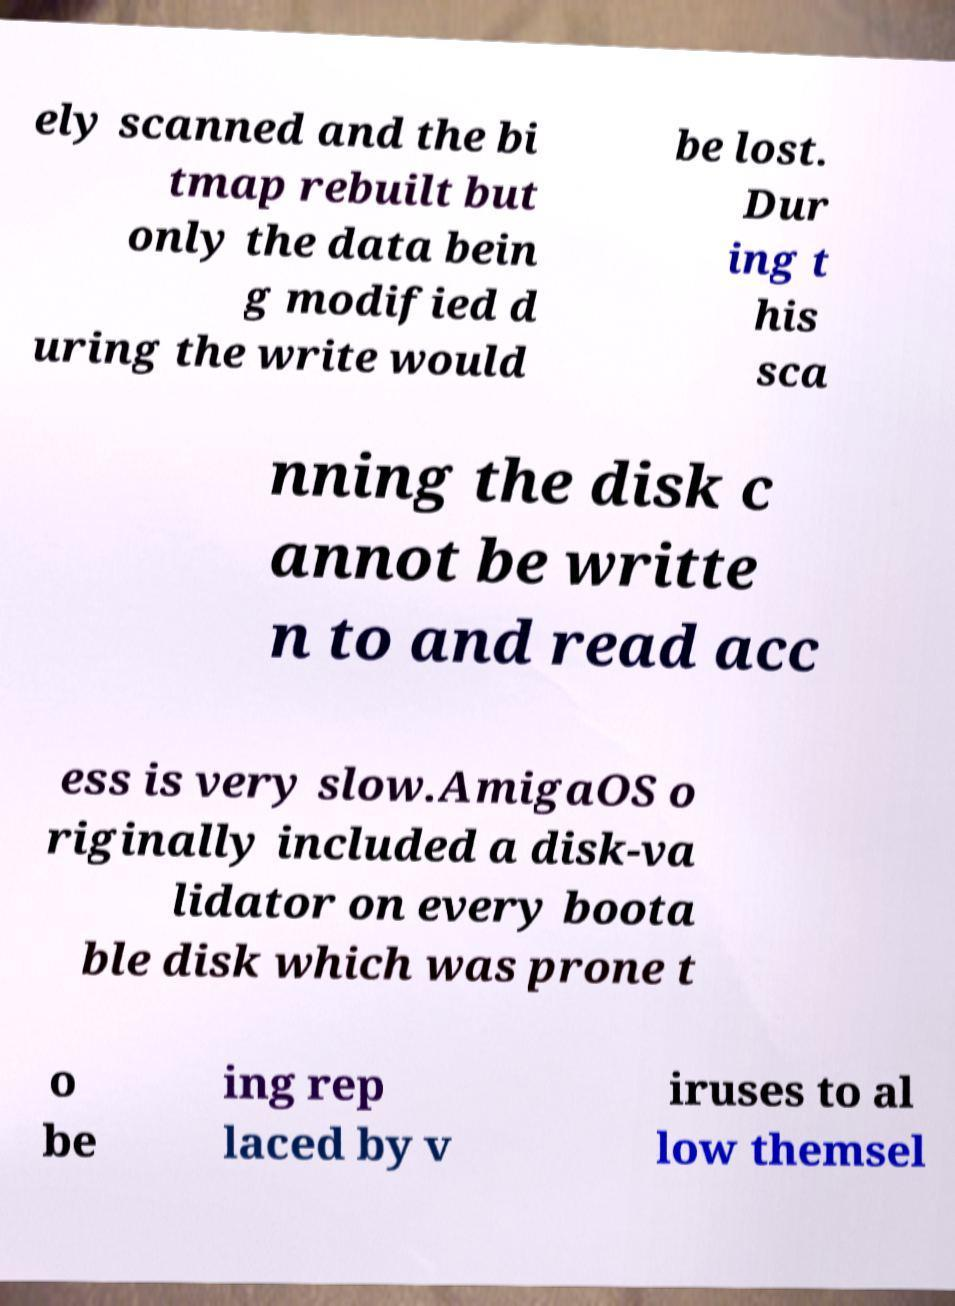For documentation purposes, I need the text within this image transcribed. Could you provide that? ely scanned and the bi tmap rebuilt but only the data bein g modified d uring the write would be lost. Dur ing t his sca nning the disk c annot be writte n to and read acc ess is very slow.AmigaOS o riginally included a disk-va lidator on every boota ble disk which was prone t o be ing rep laced by v iruses to al low themsel 